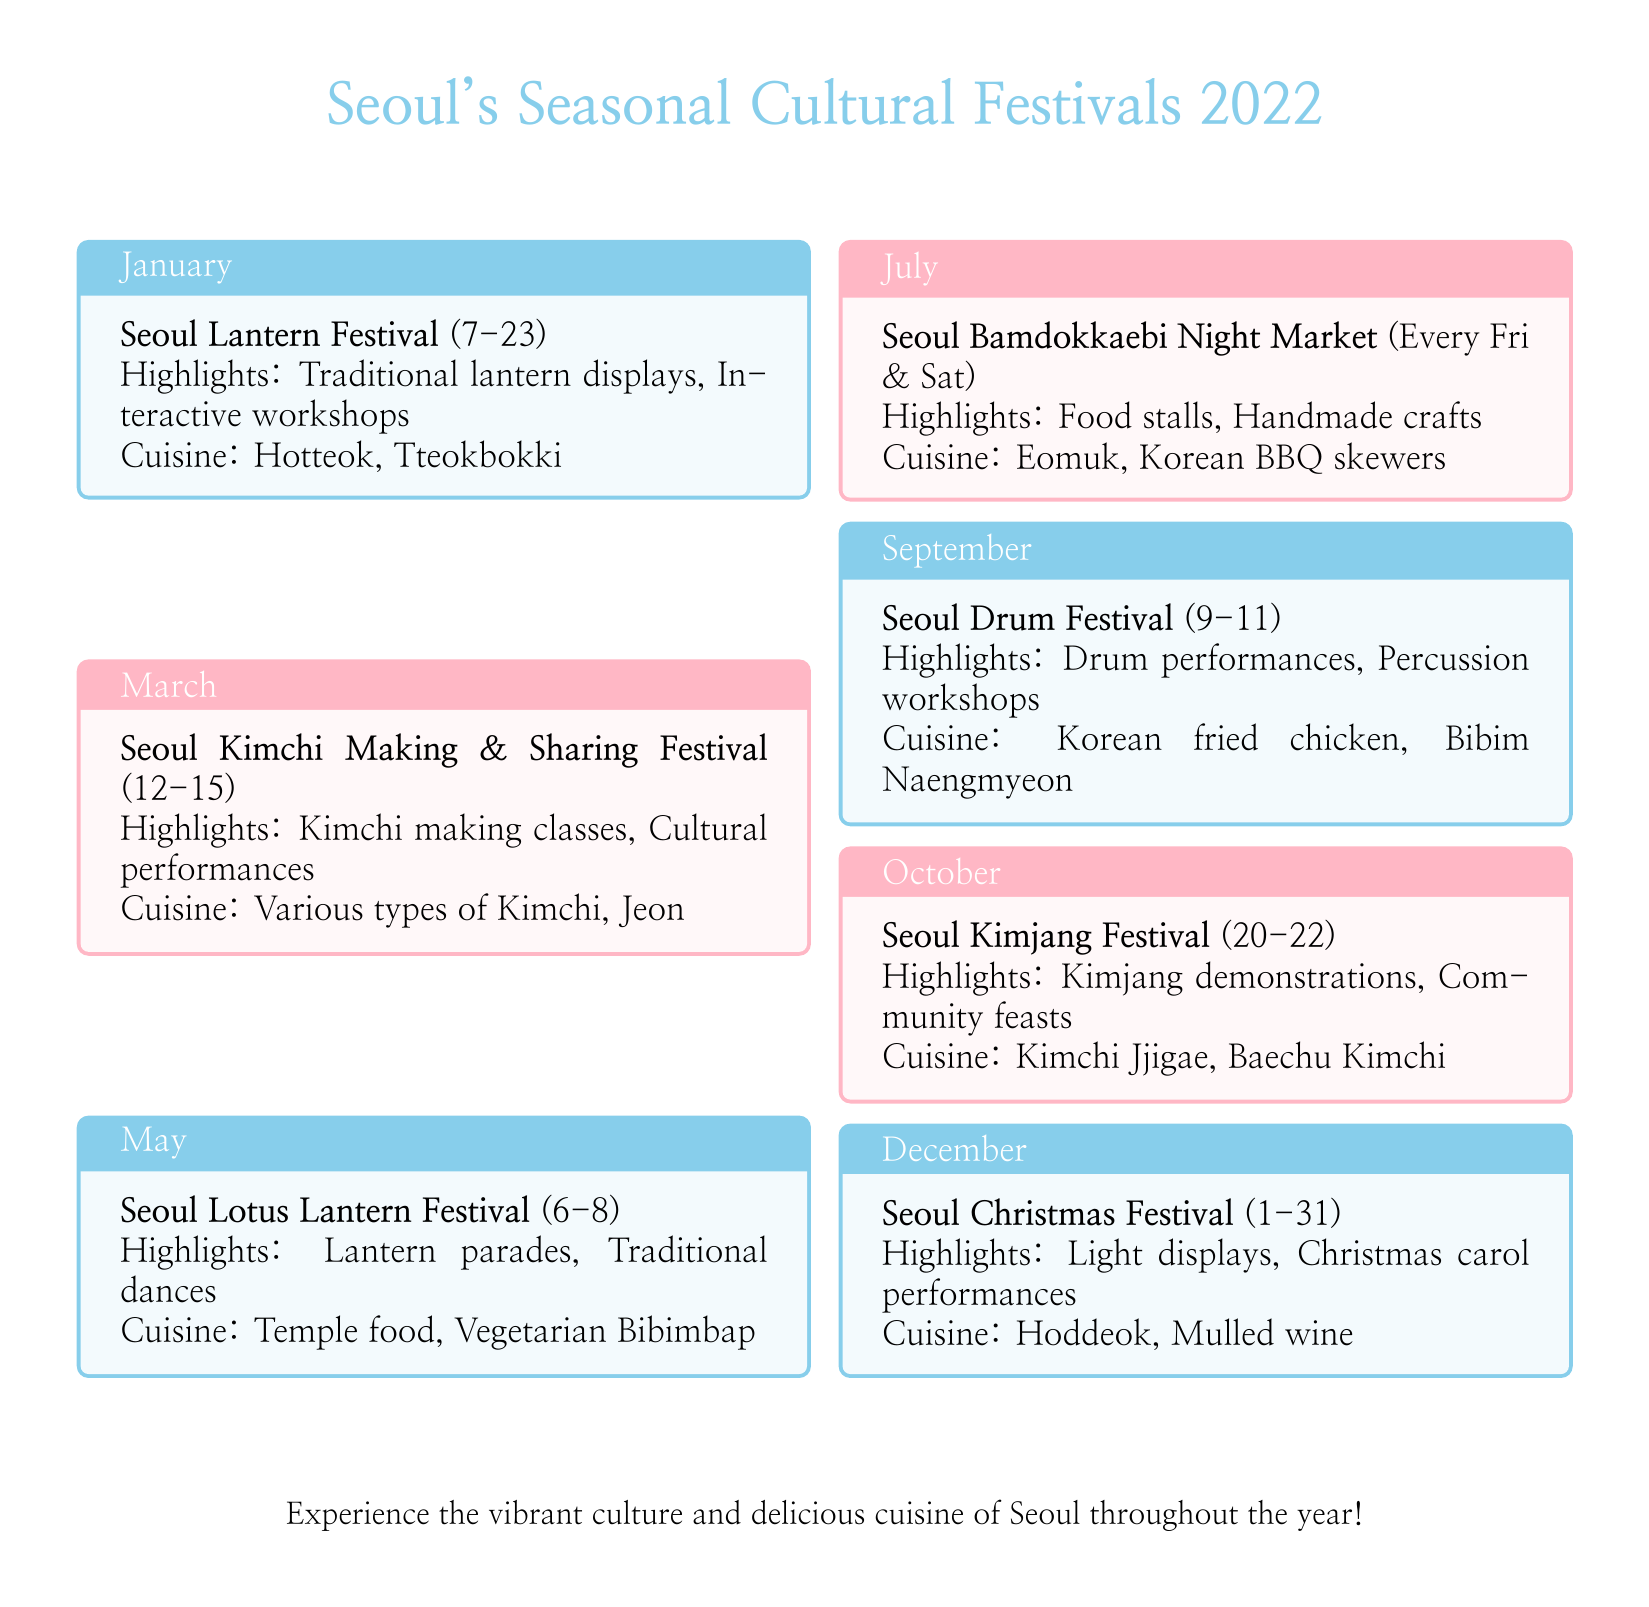What is the date range for the Seoul Lantern Festival? The Seoul Lantern Festival runs from the 7th to the 23rd of January.
Answer: 7-23 What cuisine is associated with the Seoul Kimjang Festival? The document mentions Kimchi Jjigae and Baechu Kimchi as the cuisine for the Seoul Kimjang Festival.
Answer: Kimchi Jjigae, Baechu Kimchi When does the Seoul Bamdokkaebi Night Market occur? The Seoul Bamdokkaebi Night Market takes place every Friday and Saturday.
Answer: Every Fri & Sat Which festival features traditional dances? The Seoul Lotus Lantern Festival is highlighted for its traditional dances.
Answer: Seoul Lotus Lantern Festival What highlights can you expect at the Seoul Drum Festival? The highlights of the Seoul Drum Festival include drum performances and percussion workshops.
Answer: Drum performances, Percussion workshops In which month does the Christmas Festival take place? According to the document, the Seoul Christmas Festival occurs throughout December.
Answer: December How many days does the Seoul Kimchi Making & Sharing Festival last? The Seoul Kimchi Making & Sharing Festival lasts for four days, from the 12th to the 15th of March.
Answer: 4 days What type of food is served at the Seoul Lotus Lantern Festival? The document lists temple food and vegetarian bibimbap as the cuisines available at the Seoul Lotus Lantern Festival.
Answer: Temple food, Vegetarian Bibimbap 